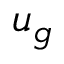<formula> <loc_0><loc_0><loc_500><loc_500>u _ { g }</formula> 